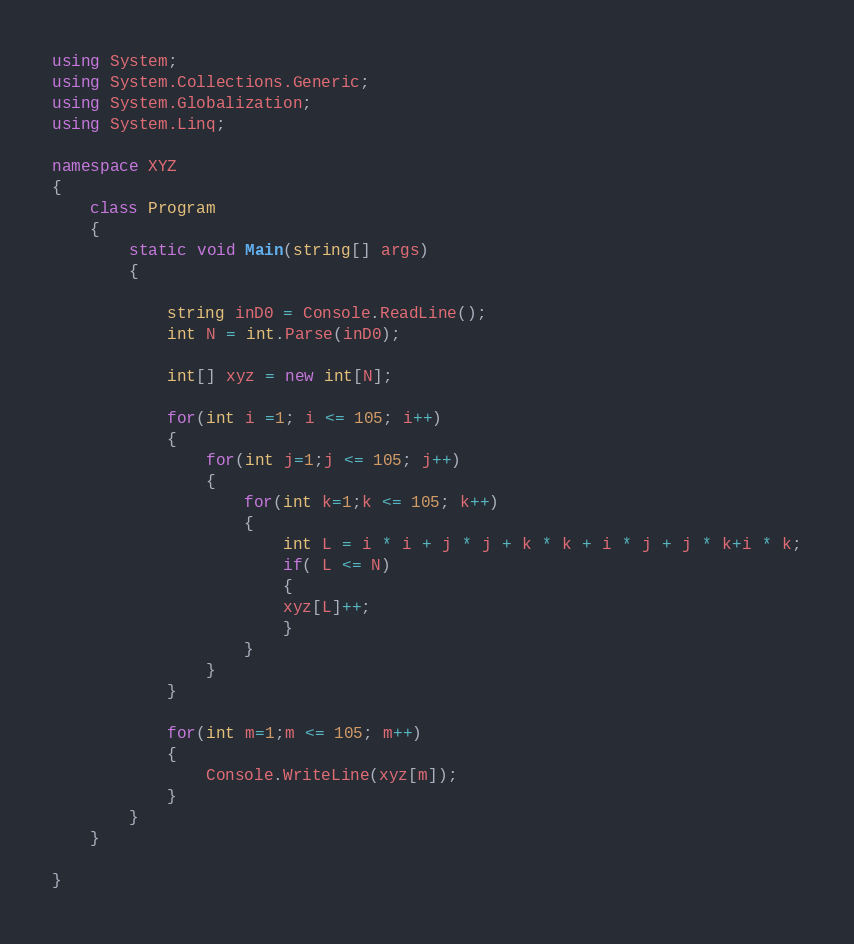<code> <loc_0><loc_0><loc_500><loc_500><_C#_>using System;
using System.Collections.Generic;
using System.Globalization;
using System.Linq;

namespace XYZ
{
    class Program
    {
        static void Main(string[] args)
        {

            string inD0 = Console.ReadLine();
            int N = int.Parse(inD0);

            int[] xyz = new int[N];

            for(int i =1; i <= 105; i++)
            {
                for(int j=1;j <= 105; j++)
                {
                    for(int k=1;k <= 105; k++)
                    {
                        int L = i * i + j * j + k * k + i * j + j * k+i * k;
                        if( L <= N)
                        {
                        xyz[L]++;
 						}
                    }
                }
            }

            for(int m=1;m <= 105; m++)
            {
                Console.WriteLine(xyz[m]);
            }
        }
    }

}
</code> 